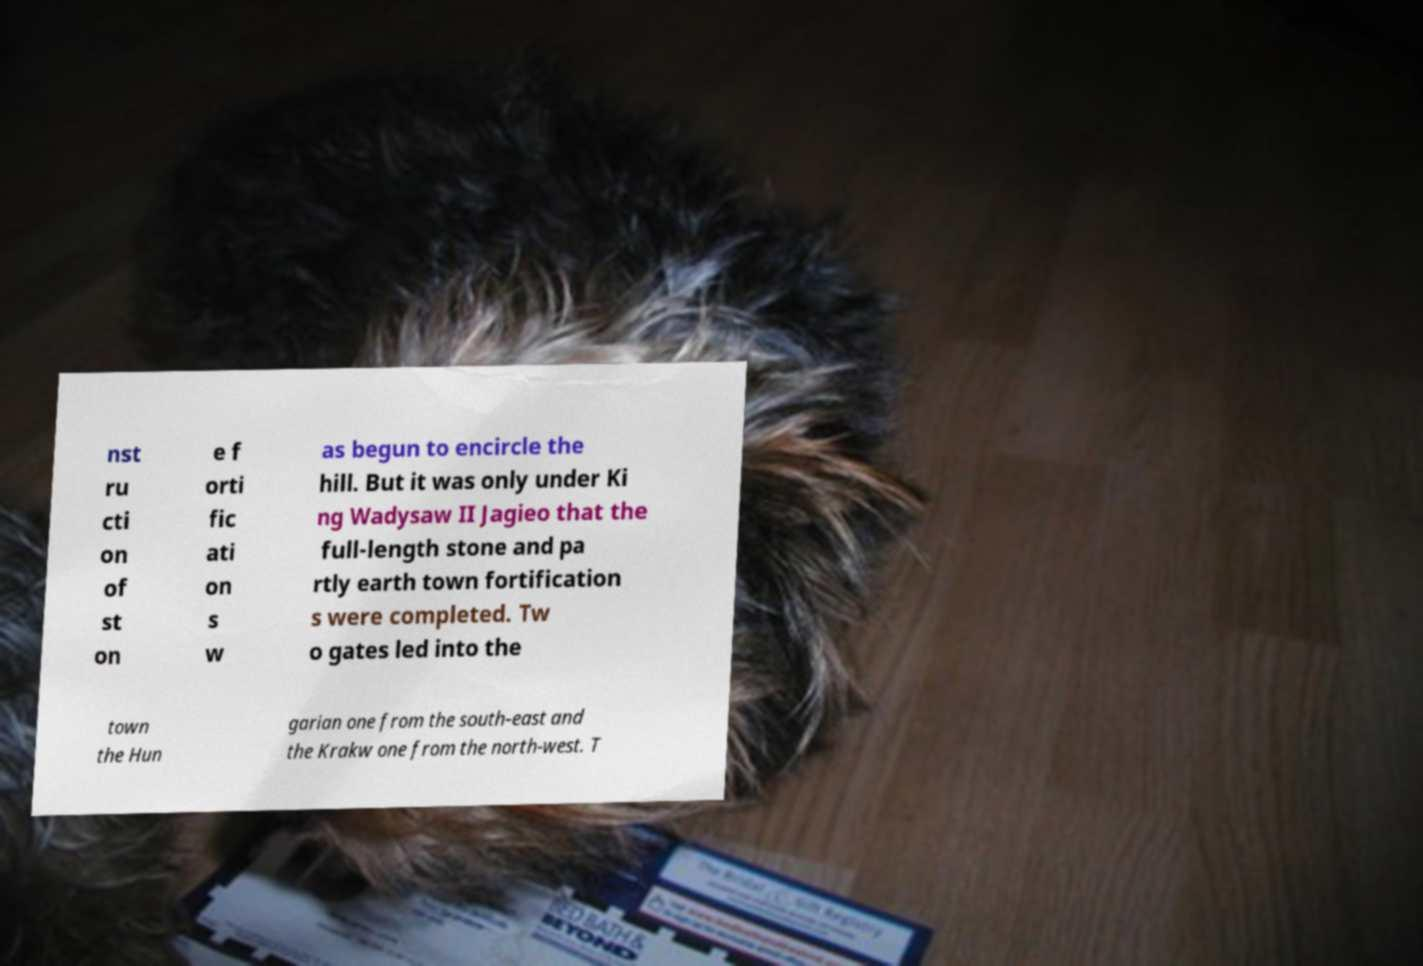Could you assist in decoding the text presented in this image and type it out clearly? nst ru cti on of st on e f orti fic ati on s w as begun to encircle the hill. But it was only under Ki ng Wadysaw II Jagieo that the full-length stone and pa rtly earth town fortification s were completed. Tw o gates led into the town the Hun garian one from the south-east and the Krakw one from the north-west. T 